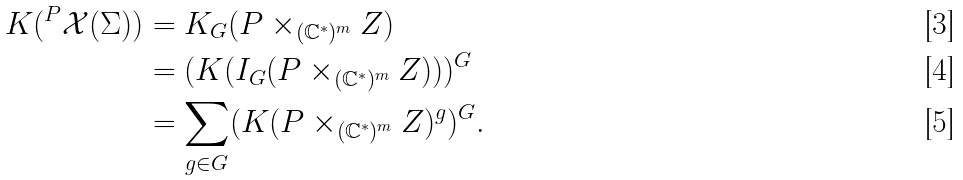<formula> <loc_0><loc_0><loc_500><loc_500>K ( ^ { P } \mathcal { X } ( \Sigma ) ) & = K _ { G } ( P \times _ { ( \mathbb { C } ^ { * } ) ^ { m } } Z ) \\ & = ( K ( I _ { G } ( P \times _ { ( \mathbb { C } ^ { * } ) ^ { m } } Z ) ) ) ^ { G } \\ & = \sum _ { g \in G } ( K ( P \times _ { ( \mathbb { C } ^ { * } ) ^ { m } } Z ) ^ { g } ) ^ { G } .</formula> 